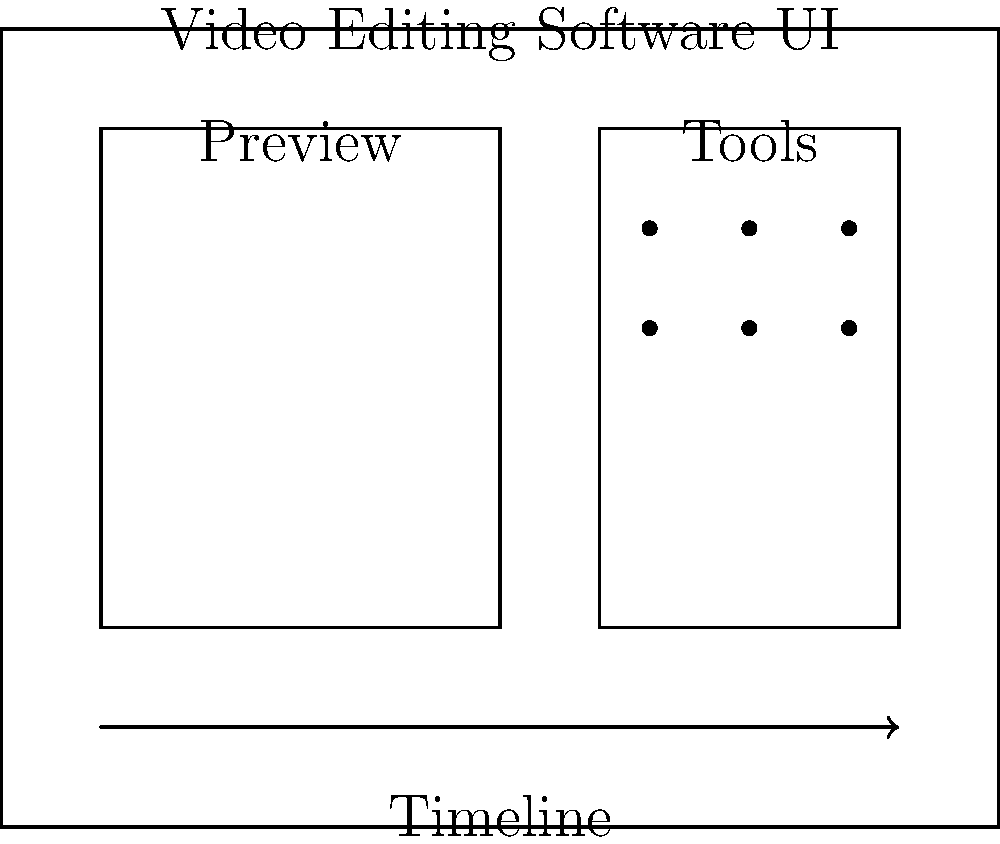As an animation designer working on screencasting projects, you're tasked with designing an intuitive user interface for a video editing software. Based on the diagram, which essential element is prominently featured at the bottom of the interface, and why is it crucial for efficient video editing? To answer this question, let's analyze the diagram step-by-step:

1. The diagram shows a layout for a video editing software interface.
2. The interface is divided into three main sections: Preview, Tools, and a horizontal element at the bottom.
3. The horizontal element at the bottom is labeled "Timeline" and is represented by an arrow pointing to the right.
4. In video editing, the timeline is crucial for several reasons:
   a) It provides a visual representation of the video's duration.
   b) It allows editors to see and manipulate the sequence of clips, effects, and transitions.
   c) It enables precise control over the timing of various elements in the video.
   d) It facilitates easy navigation through the video project.
5. For screencasting projects, the timeline is particularly important because it allows the animation designer to:
   a) Synchronize narration with on-screen actions.
   b) Add and adjust the duration of annotations or callouts.
   c) Fine-tune the pacing of the screencast for optimal viewer engagement.
6. The prominence of the timeline at the bottom of the interface makes it easily accessible and visible, which is essential for efficient video editing workflows.

Given these points, the essential element prominently featured at the bottom of the interface is the timeline, and it's crucial for efficient video editing due to its role in organizing, visualizing, and manipulating the temporal aspects of the video project.
Answer: Timeline; enables visual representation and manipulation of video sequence and timing. 